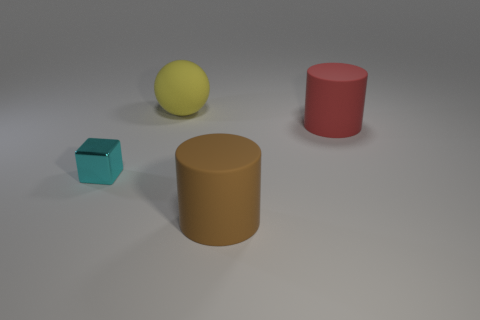How many rubber things are either red cylinders or brown balls? In the image, there is one red cylinder and no brown balls. So, the total count of rubber things that are either red cylinders or brown balls is one. 